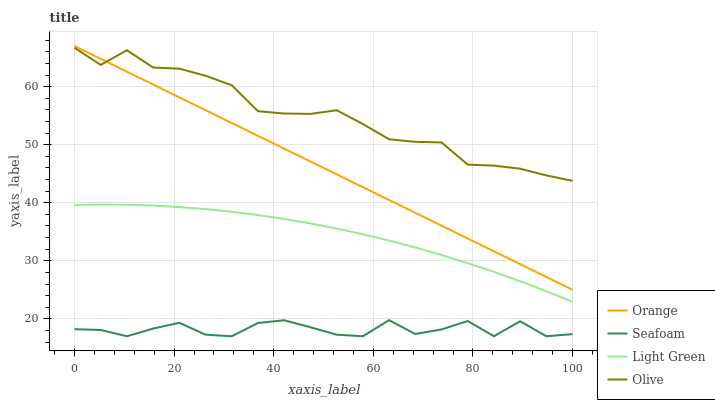Does Seafoam have the minimum area under the curve?
Answer yes or no. Yes. Does Olive have the maximum area under the curve?
Answer yes or no. Yes. Does Olive have the minimum area under the curve?
Answer yes or no. No. Does Seafoam have the maximum area under the curve?
Answer yes or no. No. Is Orange the smoothest?
Answer yes or no. Yes. Is Seafoam the roughest?
Answer yes or no. Yes. Is Olive the smoothest?
Answer yes or no. No. Is Olive the roughest?
Answer yes or no. No. Does Seafoam have the lowest value?
Answer yes or no. Yes. Does Olive have the lowest value?
Answer yes or no. No. Does Orange have the highest value?
Answer yes or no. Yes. Does Olive have the highest value?
Answer yes or no. No. Is Seafoam less than Light Green?
Answer yes or no. Yes. Is Olive greater than Seafoam?
Answer yes or no. Yes. Does Olive intersect Orange?
Answer yes or no. Yes. Is Olive less than Orange?
Answer yes or no. No. Is Olive greater than Orange?
Answer yes or no. No. Does Seafoam intersect Light Green?
Answer yes or no. No. 